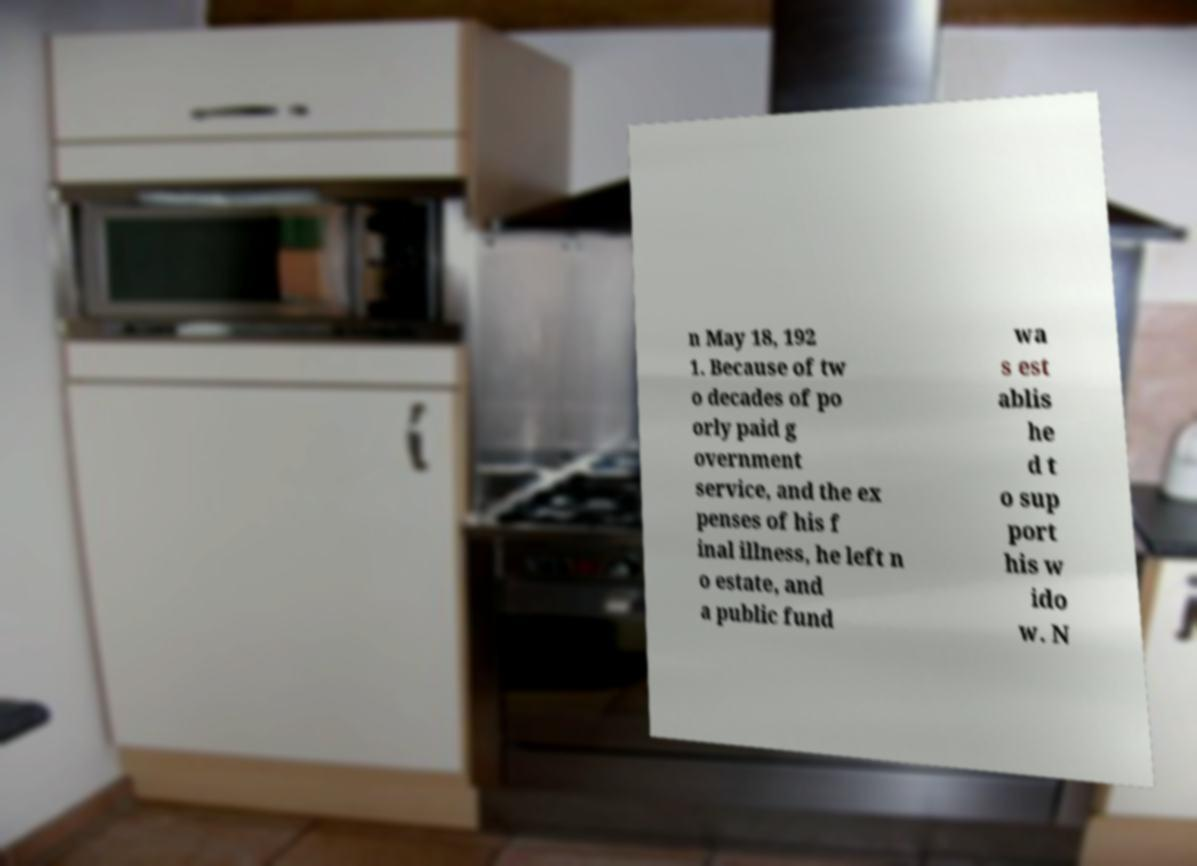What messages or text are displayed in this image? I need them in a readable, typed format. n May 18, 192 1. Because of tw o decades of po orly paid g overnment service, and the ex penses of his f inal illness, he left n o estate, and a public fund wa s est ablis he d t o sup port his w ido w. N 